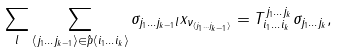Convert formula to latex. <formula><loc_0><loc_0><loc_500><loc_500>\sum _ { l } \sum _ { \langle j _ { 1 } \dots j _ { k - 1 } \rangle \in \hat { p } \langle i _ { 1 } \dots i _ { k } \rangle } \sigma _ { j _ { 1 } \dots j _ { k - 1 } l } x _ { \nu _ { \langle j _ { 1 } \dots j _ { k - 1 } \rangle } } = T ^ { j _ { 1 } \dots j _ { k } } _ { i _ { 1 } \dots i _ { k } } \sigma _ { j _ { 1 } \dots j _ { k } } ,</formula> 